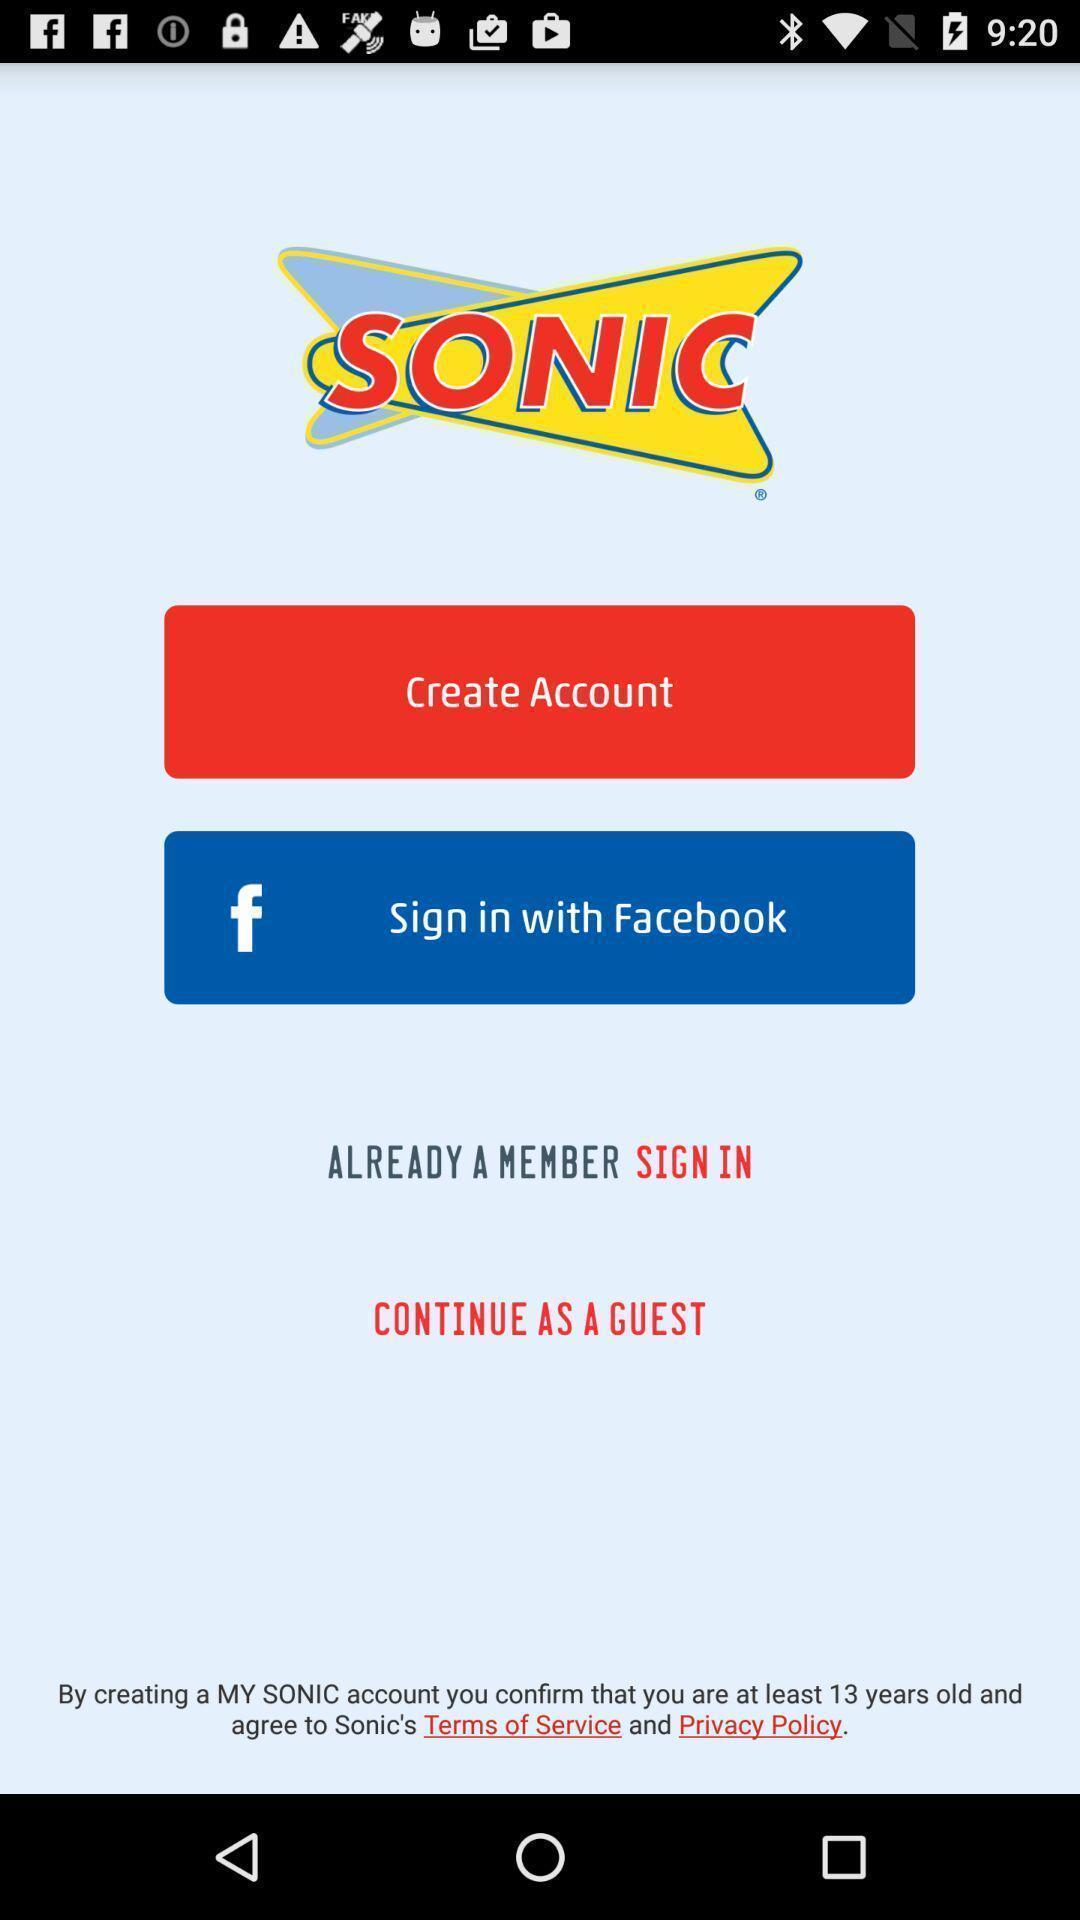Please provide a description for this image. Sign-in page of a social app. 